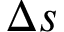Convert formula to latex. <formula><loc_0><loc_0><loc_500><loc_500>\Delta s</formula> 